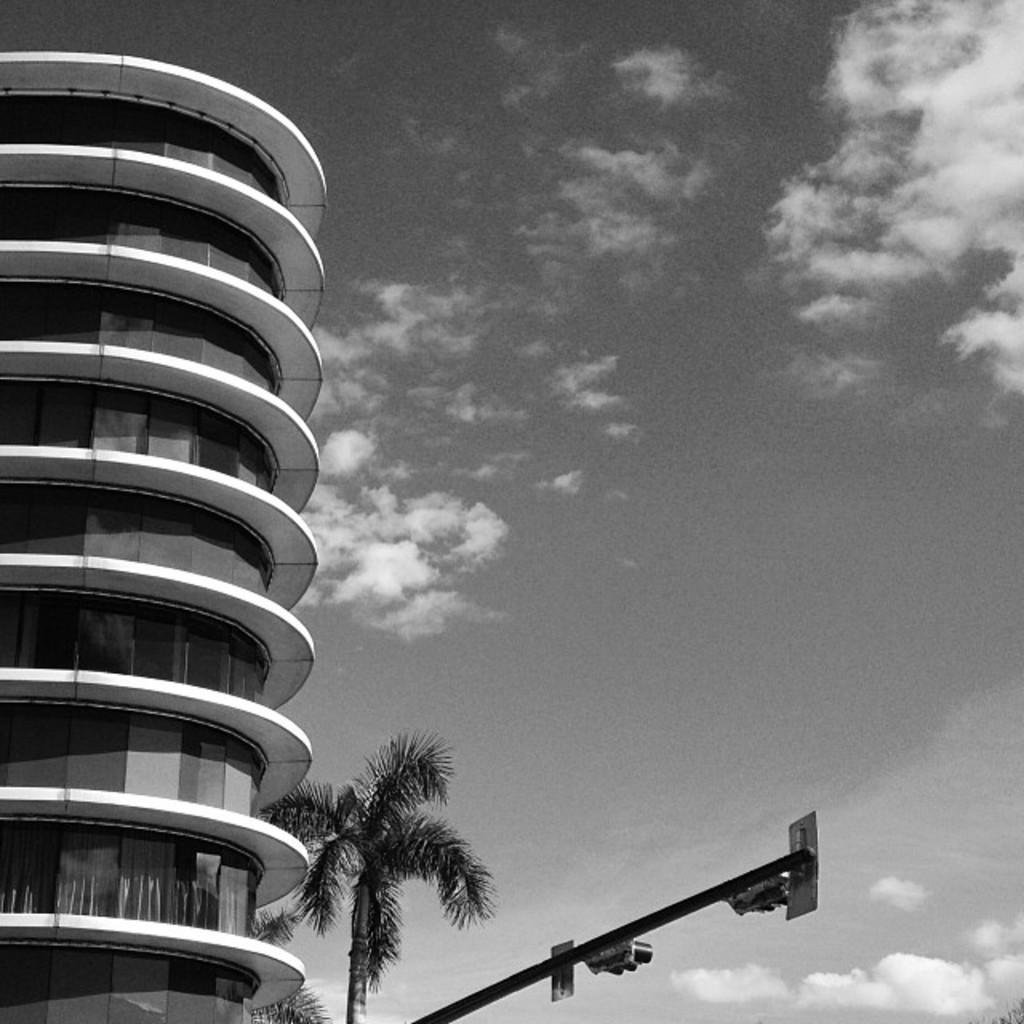Could you give a brief overview of what you see in this image? This is a black and white picture. I can see a building, there are trees, there are signal lights to the pole, and in the background there is sky. 